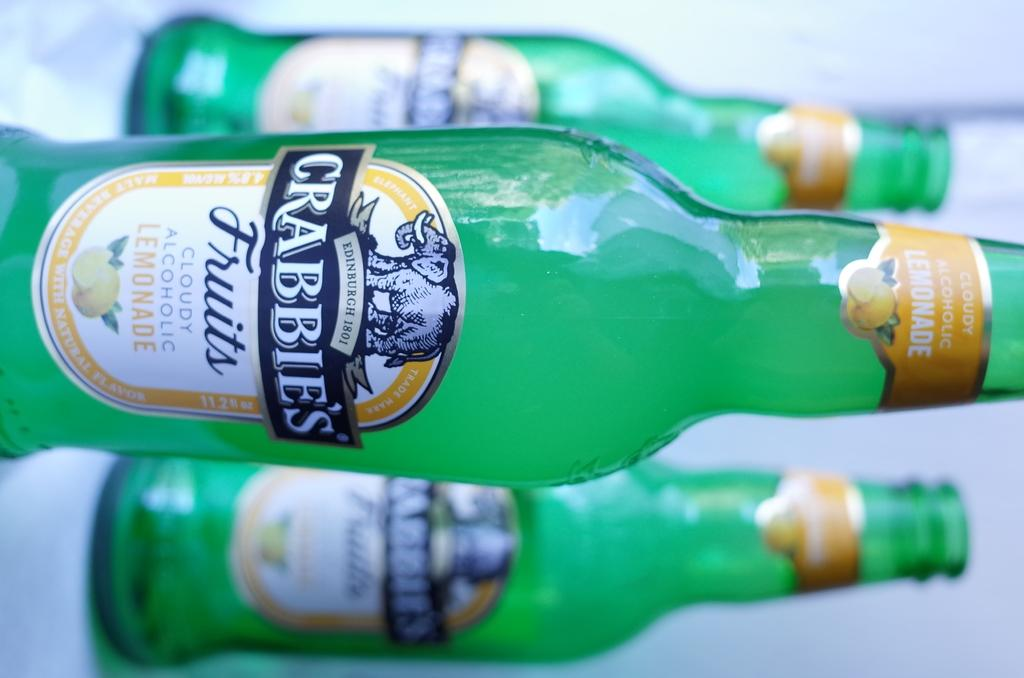Provide a one-sentence caption for the provided image. A sideways view of three bottles with the label Crabbie's fruits. 